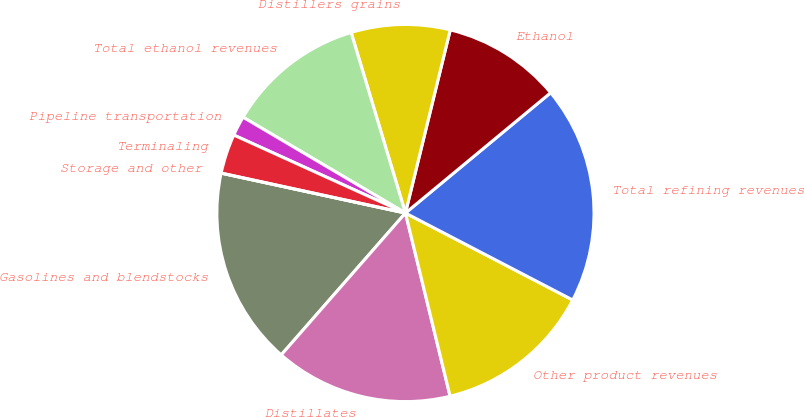Convert chart to OTSL. <chart><loc_0><loc_0><loc_500><loc_500><pie_chart><fcel>Gasolines and blendstocks<fcel>Distillates<fcel>Other product revenues<fcel>Total refining revenues<fcel>Ethanol<fcel>Distillers grains<fcel>Total ethanol revenues<fcel>Pipeline transportation<fcel>Terminaling<fcel>Storage and other<nl><fcel>16.95%<fcel>15.25%<fcel>13.56%<fcel>18.64%<fcel>10.17%<fcel>8.47%<fcel>11.86%<fcel>1.7%<fcel>3.39%<fcel>0.0%<nl></chart> 